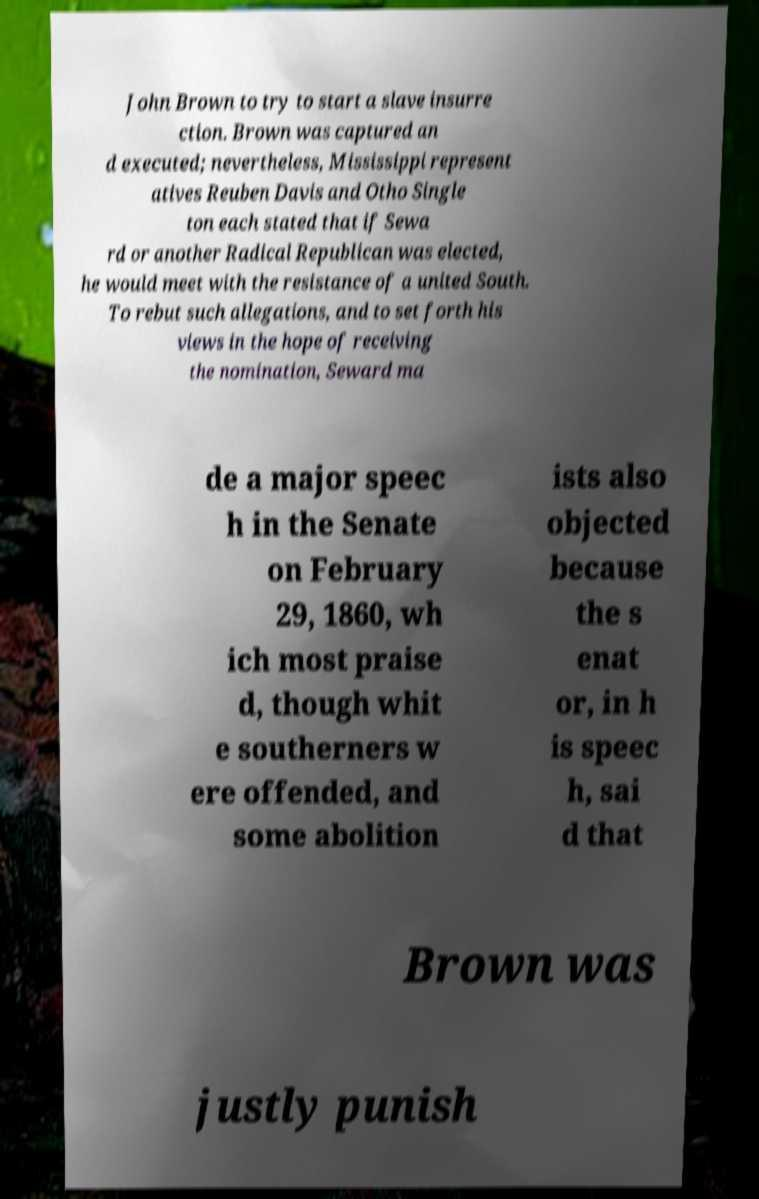Could you extract and type out the text from this image? John Brown to try to start a slave insurre ction. Brown was captured an d executed; nevertheless, Mississippi represent atives Reuben Davis and Otho Single ton each stated that if Sewa rd or another Radical Republican was elected, he would meet with the resistance of a united South. To rebut such allegations, and to set forth his views in the hope of receiving the nomination, Seward ma de a major speec h in the Senate on February 29, 1860, wh ich most praise d, though whit e southerners w ere offended, and some abolition ists also objected because the s enat or, in h is speec h, sai d that Brown was justly punish 